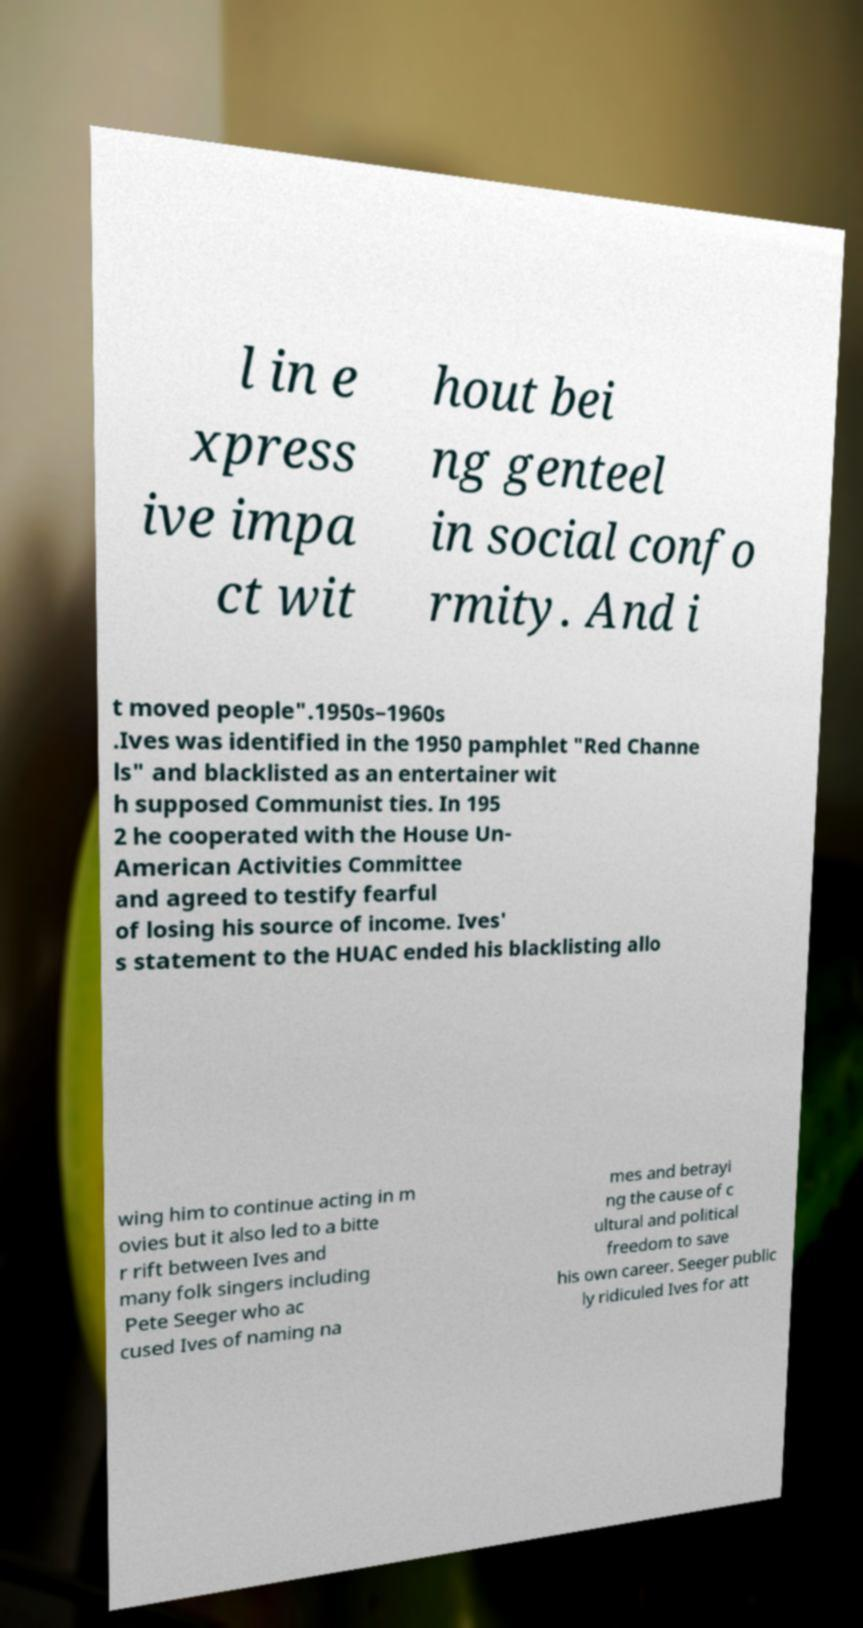Could you extract and type out the text from this image? l in e xpress ive impa ct wit hout bei ng genteel in social confo rmity. And i t moved people".1950s–1960s .Ives was identified in the 1950 pamphlet "Red Channe ls" and blacklisted as an entertainer wit h supposed Communist ties. In 195 2 he cooperated with the House Un- American Activities Committee and agreed to testify fearful of losing his source of income. Ives' s statement to the HUAC ended his blacklisting allo wing him to continue acting in m ovies but it also led to a bitte r rift between Ives and many folk singers including Pete Seeger who ac cused Ives of naming na mes and betrayi ng the cause of c ultural and political freedom to save his own career. Seeger public ly ridiculed Ives for att 